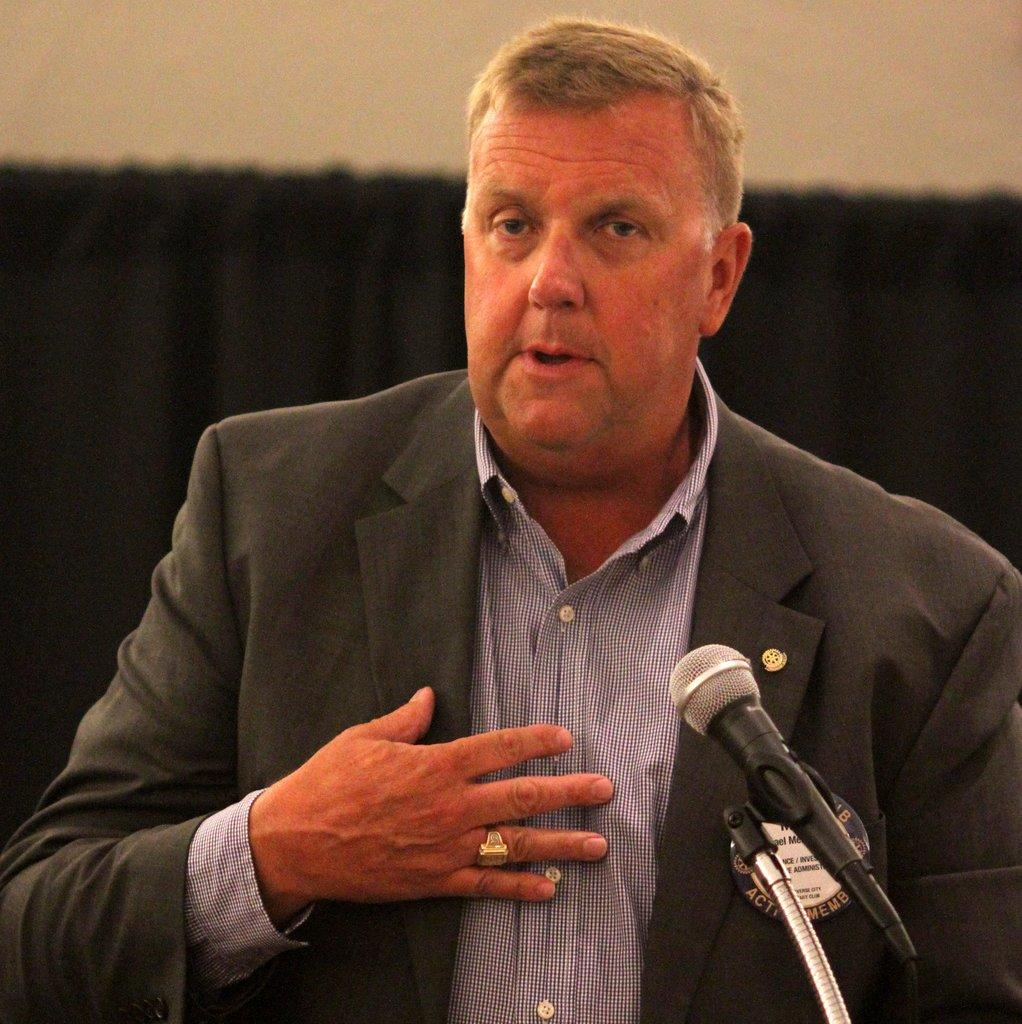Who is present in the image? There is a man in the image. What is the man doing in the image? The man is talking in the image. What object can be seen on the right side of the image? There is a microphone on the right side of the image. How many apples are hanging from the microphone in the image? There are no apples present in the image, and therefore no such objects can be observed hanging from the microphone. 